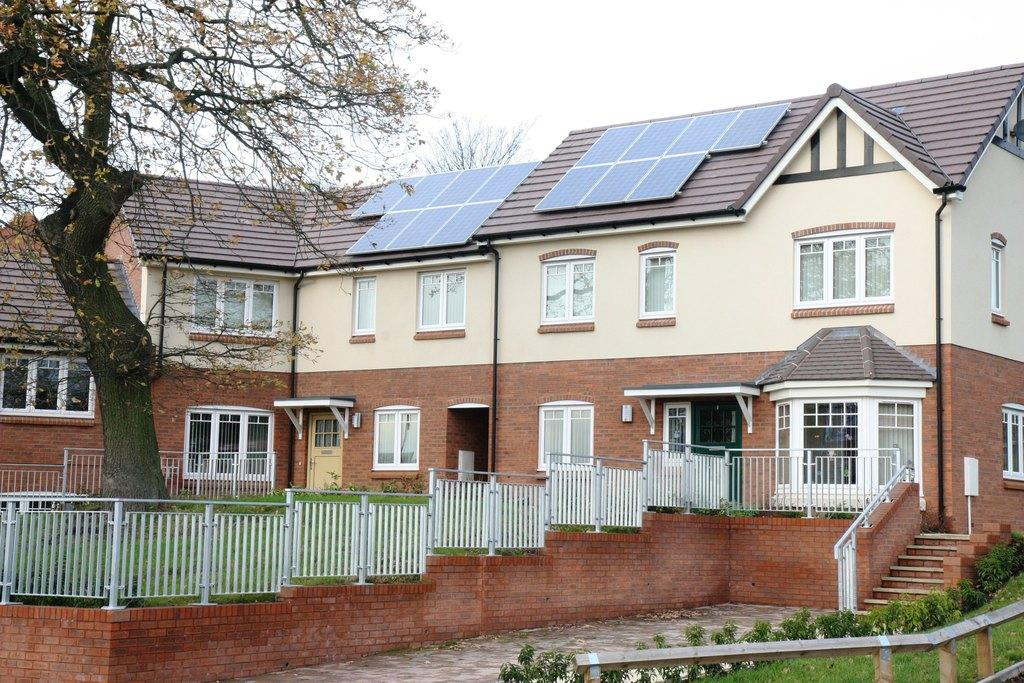What type of structure is in the image? There is a house in the image. What is located in front of the house? There is a tree in front of the house. What architectural feature can be seen in the image? Iron grilles are present in the image. What type of surface is visible in the image? Walls are visible in the image. What is used for ascending or descending in the image? Steps are present in the image. What type of vegetation is in the image? Plants are in the image. What type of ground cover is visible in the image? Grass is visible in the image. What part of the natural environment is visible behind the house? The sky is visible behind the house. What type of education is being offered to the plants in the image? There is no indication in the image that the plants are receiving any education. 